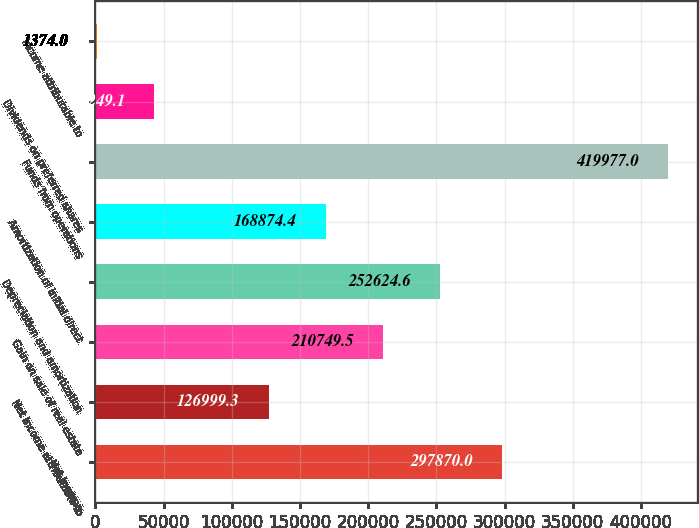<chart> <loc_0><loc_0><loc_500><loc_500><bar_chart><fcel>Net income<fcel>Net income attributable to<fcel>Gain on sale of real estate<fcel>Depreciation and amortization<fcel>Amortization of initial direct<fcel>Funds from operations<fcel>Dividends on preferred shares<fcel>Income attributable to<nl><fcel>297870<fcel>126999<fcel>210750<fcel>252625<fcel>168874<fcel>419977<fcel>43249.1<fcel>1374<nl></chart> 